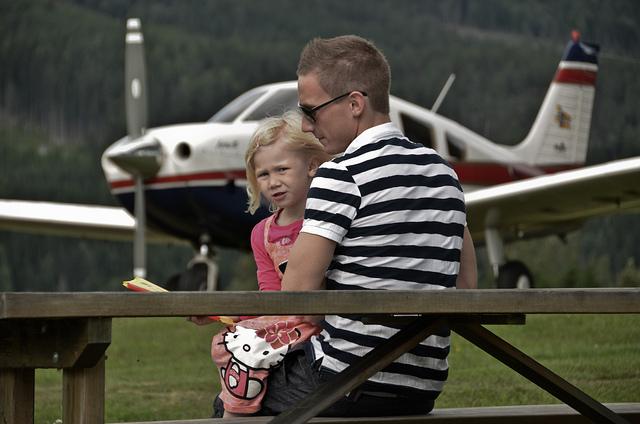What cartoon character is on her outfit?
Keep it brief. Hello kitty. What is the little girl doing with her face?
Keep it brief. Frowning. What mode of transportation is in the picture?
Concise answer only. Plane. 